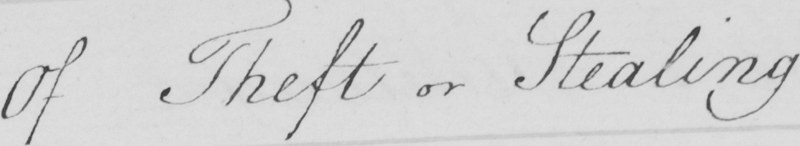Can you tell me what this handwritten text says? Of Theft or Stealing 